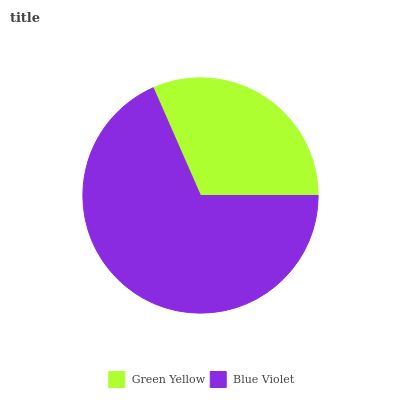Is Green Yellow the minimum?
Answer yes or no. Yes. Is Blue Violet the maximum?
Answer yes or no. Yes. Is Blue Violet the minimum?
Answer yes or no. No. Is Blue Violet greater than Green Yellow?
Answer yes or no. Yes. Is Green Yellow less than Blue Violet?
Answer yes or no. Yes. Is Green Yellow greater than Blue Violet?
Answer yes or no. No. Is Blue Violet less than Green Yellow?
Answer yes or no. No. Is Blue Violet the high median?
Answer yes or no. Yes. Is Green Yellow the low median?
Answer yes or no. Yes. Is Green Yellow the high median?
Answer yes or no. No. Is Blue Violet the low median?
Answer yes or no. No. 